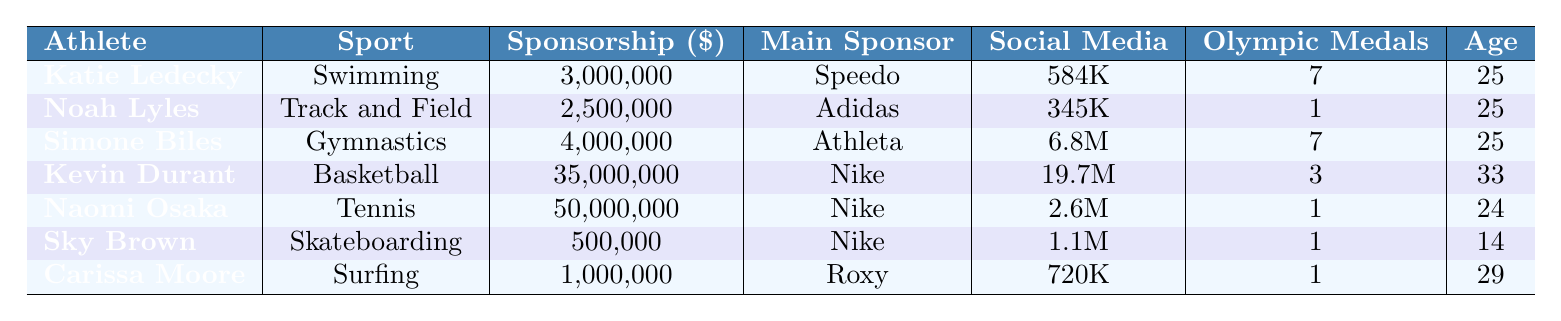What is the sponsorship value of Naomi Osaka? The table lists Naomi Osaka's sponsorship value under the Sponsorship column, which shows $50,000,000.
Answer: 50,000,000 Who is the main sponsor for Katie Ledecky? In the table, the Main Sponsor column for Katie Ledecky shows Speedo as her main sponsor.
Answer: Speedo Which athlete has the highest number of Olympic medals? By looking at the Olympic Medals column, both Katie Ledecky and Simone Biles have 7 medals, which is the highest among the athletes.
Answer: Katie Ledecky and Simone Biles What is the total sponsorship value of athletes in team sports (basketball, and others represented in the table)? The athletes in team sports include Kevin Durant (35,000,000) and Naomi Osaka (50,000,000). Summing these gives 35,000,000 + 50,000,000 = 85,000,000.
Answer: 85,000,000 What proportion of the total sponsorship goes to Kevin Durant compared to the total sponsorship for all athletes? The total sponsorship values are 3,000,000 + 2,500,000 + 4,000,000 + 35,000,000 + 50,000,000 + 500,000 + 1,000,000 = 96,000,000. Kevin Durant's sponsorship is 35,000,000, so the proportion is 35,000,000 / 96,000,000 = 0.3646 (or 36.46%).
Answer: 36.46% Is the sponsorship value of Skateboarding greater than that of Surfing? Skateboarding's sponsorship value is 500,000, and Surfing's is 1,000,000 according to the table. Since 500,000 is less than 1,000,000, the statement is false.
Answer: No Which athlete is the youngest, and what sport do they compete in? The Age column shows Sky Brown at 14 years old, making her the youngest athlete in the table. Looking at the Sport column indicates she competes in Skateboarding.
Answer: Sky Brown, Skateboarding How many more social media followers does Simone Biles have compared to Noah Lyles? Simone Biles has 6,800,000 and Noah Lyles has 345,000 social media followers. The difference is 6,800,000 - 345,000 = 6,455,000.
Answer: 6,455,000 What is the average age of the athletes in the table? To find the average age, sum the ages: 25 + 25 + 25 + 33 + 24 + 14 + 29 =  175. Dividing by 7 (the number of athletes) gives an average age of 175 / 7 = 25.
Answer: 25 Is Kevin Durant the only athlete aged 33? The Age column shows Kevin Durant as 33, and there are no other athletes listed with the age 33, so he is the only one.
Answer: Yes What sport has the highest sponsorship value, and what is that value? The sponsorship column shows that Kevin Durant's Basketball sponsorship value of 35,000,000 is the highest among all sports.
Answer: Basketball, 35,000,000 